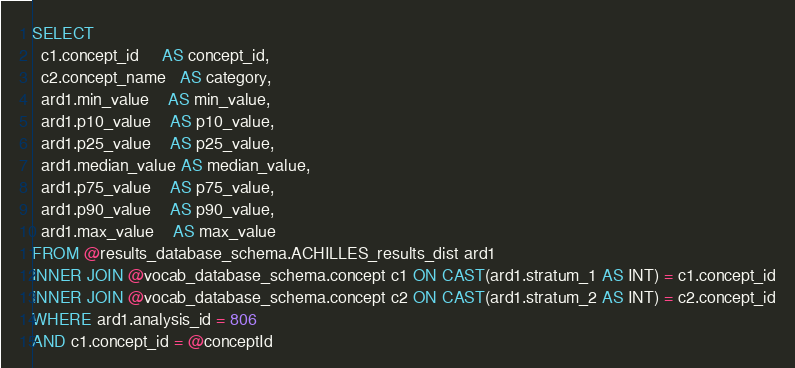<code> <loc_0><loc_0><loc_500><loc_500><_SQL_>SELECT
  c1.concept_id     AS concept_id,
  c2.concept_name   AS category,
  ard1.min_value    AS min_value,
  ard1.p10_value    AS p10_value,
  ard1.p25_value    AS p25_value,
  ard1.median_value AS median_value,
  ard1.p75_value    AS p75_value,
  ard1.p90_value    AS p90_value,
  ard1.max_value    AS max_value
FROM @results_database_schema.ACHILLES_results_dist ard1
INNER JOIN @vocab_database_schema.concept c1 ON CAST(ard1.stratum_1 AS INT) = c1.concept_id
INNER JOIN @vocab_database_schema.concept c2 ON CAST(ard1.stratum_2 AS INT) = c2.concept_id
WHERE ard1.analysis_id = 806
AND c1.concept_id = @conceptId
</code> 